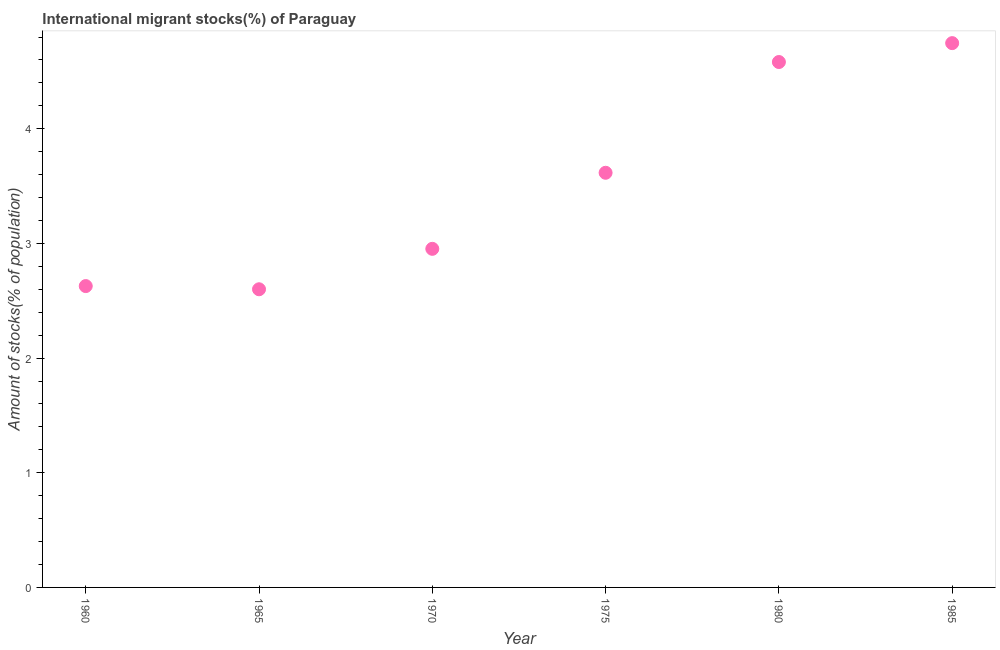What is the number of international migrant stocks in 1970?
Offer a very short reply. 2.95. Across all years, what is the maximum number of international migrant stocks?
Your response must be concise. 4.75. Across all years, what is the minimum number of international migrant stocks?
Your response must be concise. 2.6. In which year was the number of international migrant stocks minimum?
Give a very brief answer. 1965. What is the sum of the number of international migrant stocks?
Offer a very short reply. 21.13. What is the difference between the number of international migrant stocks in 1970 and 1985?
Your answer should be very brief. -1.79. What is the average number of international migrant stocks per year?
Your answer should be compact. 3.52. What is the median number of international migrant stocks?
Offer a very short reply. 3.28. In how many years, is the number of international migrant stocks greater than 1.6 %?
Give a very brief answer. 6. Do a majority of the years between 1975 and 1965 (inclusive) have number of international migrant stocks greater than 1.4 %?
Your response must be concise. No. What is the ratio of the number of international migrant stocks in 1965 to that in 1980?
Ensure brevity in your answer.  0.57. Is the difference between the number of international migrant stocks in 1980 and 1985 greater than the difference between any two years?
Your answer should be compact. No. What is the difference between the highest and the second highest number of international migrant stocks?
Ensure brevity in your answer.  0.16. What is the difference between the highest and the lowest number of international migrant stocks?
Offer a very short reply. 2.15. Does the number of international migrant stocks monotonically increase over the years?
Offer a terse response. No. What is the difference between two consecutive major ticks on the Y-axis?
Offer a very short reply. 1. What is the title of the graph?
Provide a short and direct response. International migrant stocks(%) of Paraguay. What is the label or title of the Y-axis?
Give a very brief answer. Amount of stocks(% of population). What is the Amount of stocks(% of population) in 1960?
Keep it short and to the point. 2.63. What is the Amount of stocks(% of population) in 1965?
Your answer should be compact. 2.6. What is the Amount of stocks(% of population) in 1970?
Offer a very short reply. 2.95. What is the Amount of stocks(% of population) in 1975?
Your answer should be compact. 3.62. What is the Amount of stocks(% of population) in 1980?
Give a very brief answer. 4.58. What is the Amount of stocks(% of population) in 1985?
Your response must be concise. 4.75. What is the difference between the Amount of stocks(% of population) in 1960 and 1965?
Provide a short and direct response. 0.03. What is the difference between the Amount of stocks(% of population) in 1960 and 1970?
Provide a short and direct response. -0.32. What is the difference between the Amount of stocks(% of population) in 1960 and 1975?
Your response must be concise. -0.99. What is the difference between the Amount of stocks(% of population) in 1960 and 1980?
Give a very brief answer. -1.95. What is the difference between the Amount of stocks(% of population) in 1960 and 1985?
Keep it short and to the point. -2.12. What is the difference between the Amount of stocks(% of population) in 1965 and 1970?
Offer a very short reply. -0.35. What is the difference between the Amount of stocks(% of population) in 1965 and 1975?
Give a very brief answer. -1.02. What is the difference between the Amount of stocks(% of population) in 1965 and 1980?
Provide a short and direct response. -1.98. What is the difference between the Amount of stocks(% of population) in 1965 and 1985?
Give a very brief answer. -2.15. What is the difference between the Amount of stocks(% of population) in 1970 and 1975?
Offer a terse response. -0.66. What is the difference between the Amount of stocks(% of population) in 1970 and 1980?
Your response must be concise. -1.63. What is the difference between the Amount of stocks(% of population) in 1970 and 1985?
Offer a very short reply. -1.79. What is the difference between the Amount of stocks(% of population) in 1975 and 1980?
Provide a short and direct response. -0.97. What is the difference between the Amount of stocks(% of population) in 1975 and 1985?
Give a very brief answer. -1.13. What is the difference between the Amount of stocks(% of population) in 1980 and 1985?
Your response must be concise. -0.16. What is the ratio of the Amount of stocks(% of population) in 1960 to that in 1970?
Your answer should be very brief. 0.89. What is the ratio of the Amount of stocks(% of population) in 1960 to that in 1975?
Make the answer very short. 0.73. What is the ratio of the Amount of stocks(% of population) in 1960 to that in 1980?
Make the answer very short. 0.57. What is the ratio of the Amount of stocks(% of population) in 1960 to that in 1985?
Provide a succinct answer. 0.55. What is the ratio of the Amount of stocks(% of population) in 1965 to that in 1970?
Your answer should be very brief. 0.88. What is the ratio of the Amount of stocks(% of population) in 1965 to that in 1975?
Make the answer very short. 0.72. What is the ratio of the Amount of stocks(% of population) in 1965 to that in 1980?
Your answer should be very brief. 0.57. What is the ratio of the Amount of stocks(% of population) in 1965 to that in 1985?
Offer a terse response. 0.55. What is the ratio of the Amount of stocks(% of population) in 1970 to that in 1975?
Make the answer very short. 0.82. What is the ratio of the Amount of stocks(% of population) in 1970 to that in 1980?
Give a very brief answer. 0.64. What is the ratio of the Amount of stocks(% of population) in 1970 to that in 1985?
Make the answer very short. 0.62. What is the ratio of the Amount of stocks(% of population) in 1975 to that in 1980?
Your answer should be very brief. 0.79. What is the ratio of the Amount of stocks(% of population) in 1975 to that in 1985?
Give a very brief answer. 0.76. 